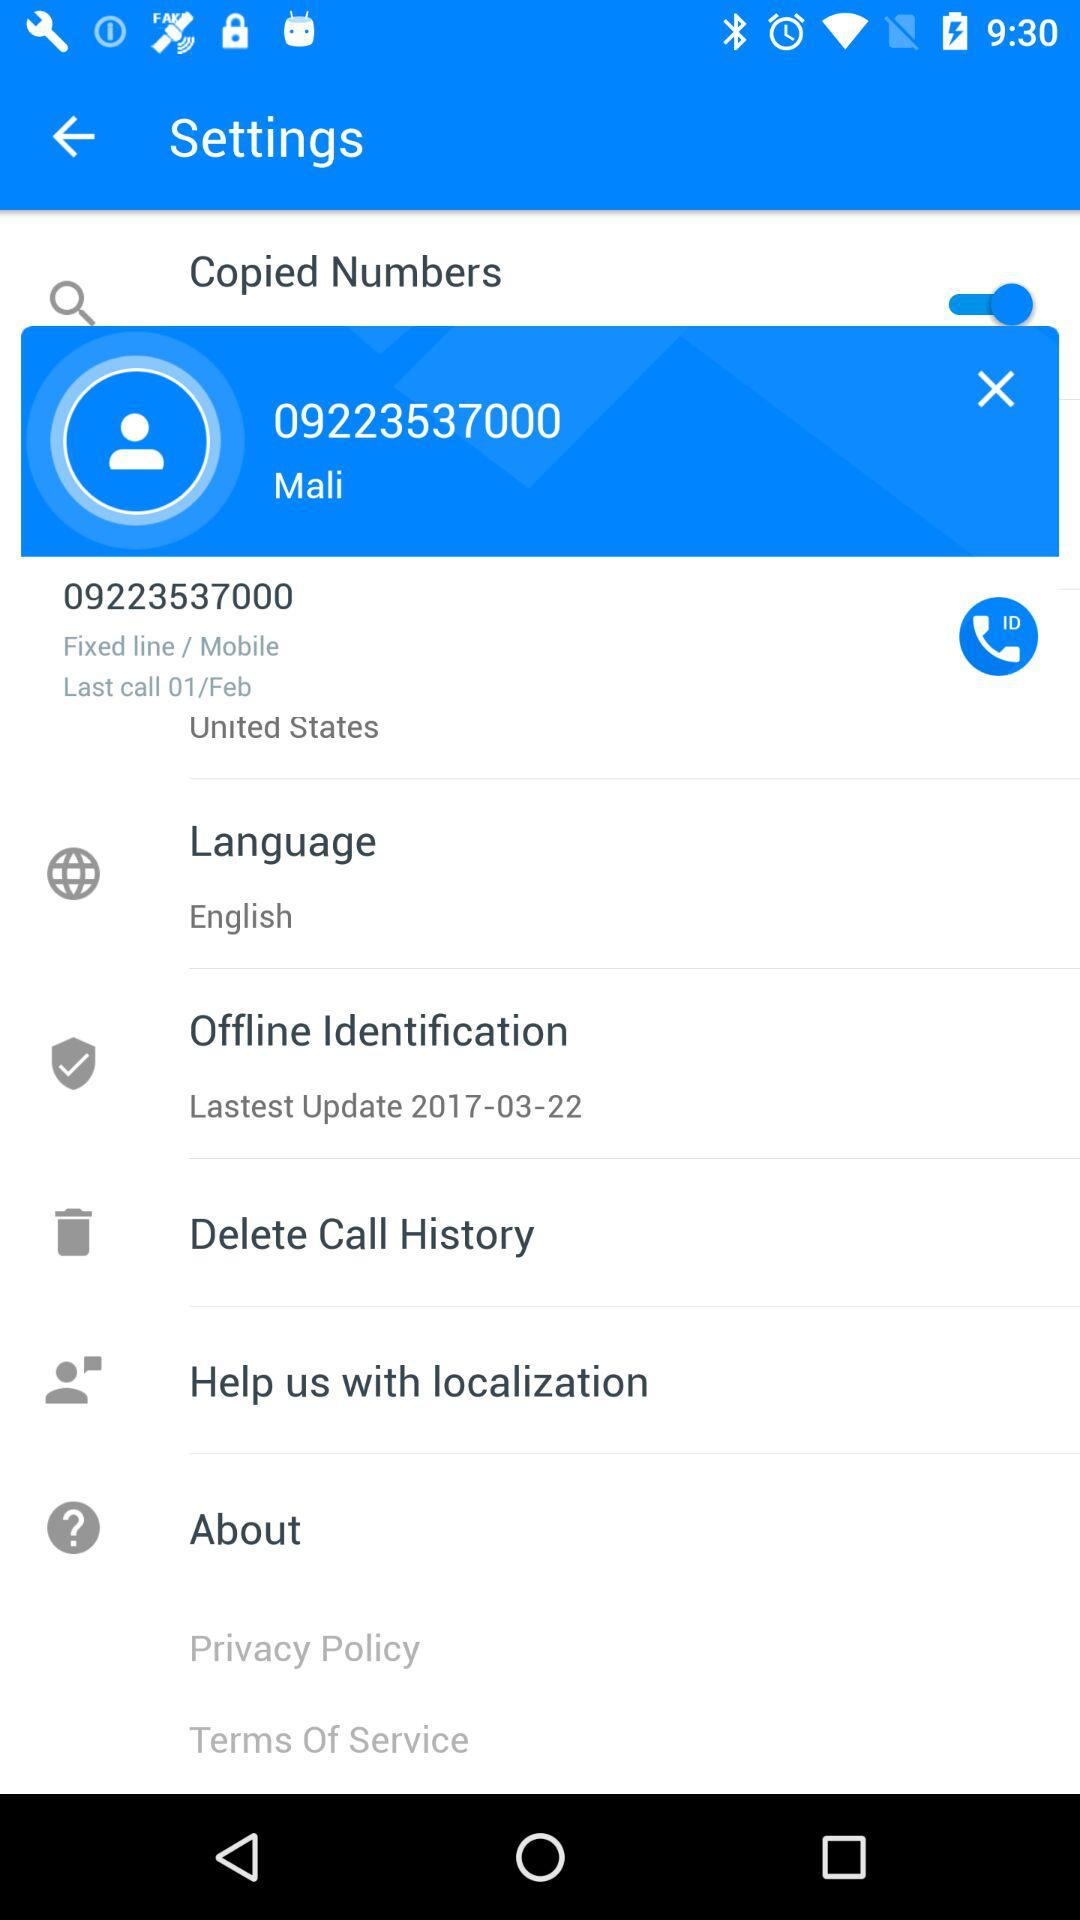What is the phone number? The phone number is 09223537000. 